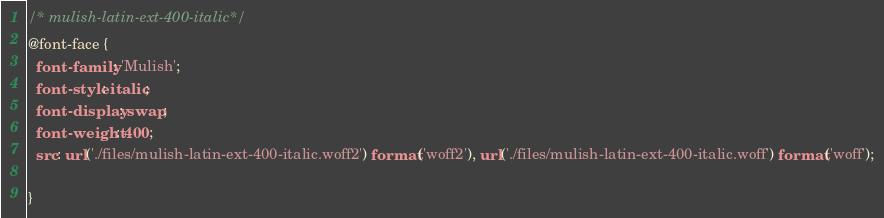<code> <loc_0><loc_0><loc_500><loc_500><_CSS_>/* mulish-latin-ext-400-italic*/
@font-face {
  font-family: 'Mulish';
  font-style: italic;
  font-display: swap;
  font-weight: 400;
  src: url('./files/mulish-latin-ext-400-italic.woff2') format('woff2'), url('./files/mulish-latin-ext-400-italic.woff') format('woff');
  
}
</code> 